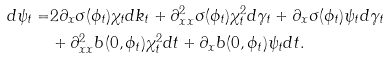<formula> <loc_0><loc_0><loc_500><loc_500>d \psi _ { t } = & 2 \partial _ { x } \sigma ( \phi _ { t } ) \chi _ { t } d k _ { t } + \partial ^ { 2 } _ { x x } \sigma ( \phi _ { t } ) \chi ^ { 2 } _ { t } d \gamma _ { t } + \partial _ { x } \sigma ( \phi _ { t } ) \psi _ { t } d \gamma _ { t } \\ & + \partial ^ { 2 } _ { x x } b ( 0 , \phi _ { t } ) \chi ^ { 2 } _ { t } d t + \partial _ { x } b ( 0 , \phi _ { t } ) \psi _ { t } d t .</formula> 